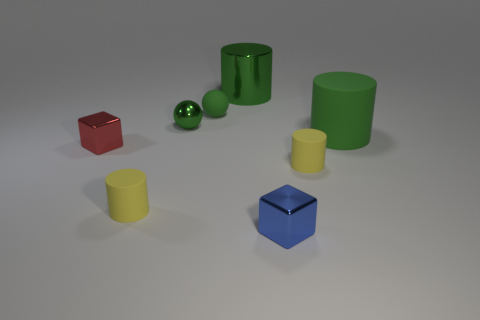What is the red object made of?
Provide a short and direct response. Metal. How many things are either big green balls or small blue metal cubes?
Keep it short and to the point. 1. Does the yellow thing that is to the right of the blue object have the same size as the block to the right of the green metallic sphere?
Your answer should be compact. Yes. How many other things are the same size as the blue shiny thing?
Offer a terse response. 5. What number of objects are tiny cylinders to the right of the metal sphere or objects that are to the left of the big matte cylinder?
Offer a terse response. 7. Are the small blue thing and the large thing that is behind the green rubber cylinder made of the same material?
Keep it short and to the point. Yes. How many other things are the same shape as the large matte object?
Give a very brief answer. 3. What is the block on the right side of the tiny shiny cube behind the metal object that is in front of the red object made of?
Provide a succinct answer. Metal. Is the number of blue metallic blocks on the right side of the blue metallic thing the same as the number of green matte objects?
Keep it short and to the point. No. Are the cylinder on the left side of the shiny ball and the big green thing that is behind the metal sphere made of the same material?
Ensure brevity in your answer.  No. 